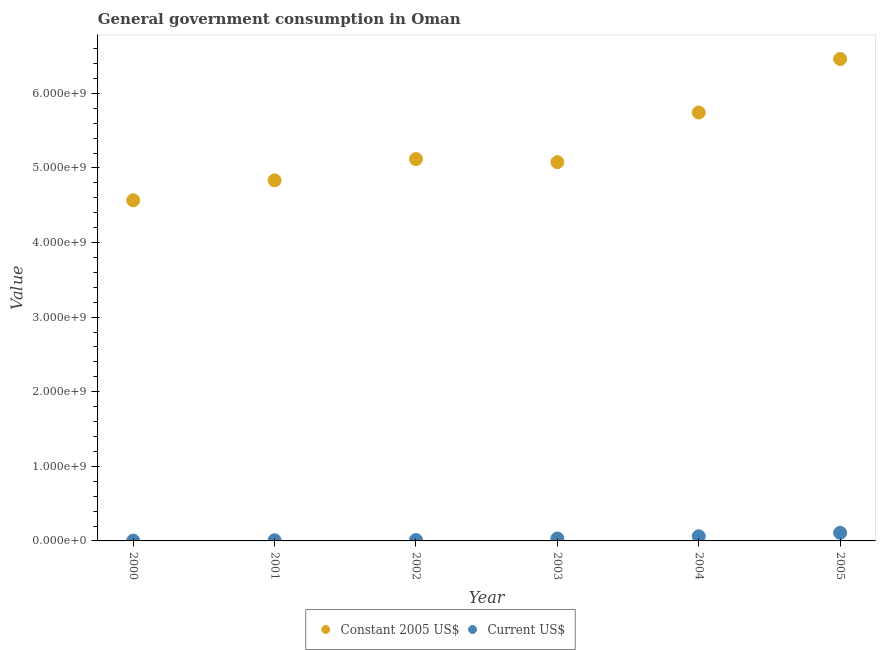What is the value consumed in constant 2005 us$ in 2001?
Your answer should be very brief. 4.83e+09. Across all years, what is the maximum value consumed in current us$?
Offer a terse response. 1.09e+08. Across all years, what is the minimum value consumed in constant 2005 us$?
Keep it short and to the point. 4.57e+09. What is the total value consumed in current us$ in the graph?
Provide a short and direct response. 2.30e+08. What is the difference between the value consumed in constant 2005 us$ in 2000 and that in 2001?
Make the answer very short. -2.68e+08. What is the difference between the value consumed in current us$ in 2003 and the value consumed in constant 2005 us$ in 2002?
Offer a very short reply. -5.09e+09. What is the average value consumed in current us$ per year?
Your answer should be compact. 3.84e+07. In the year 2002, what is the difference between the value consumed in constant 2005 us$ and value consumed in current us$?
Give a very brief answer. 5.11e+09. What is the ratio of the value consumed in constant 2005 us$ in 2003 to that in 2005?
Offer a terse response. 0.79. Is the value consumed in constant 2005 us$ in 2000 less than that in 2001?
Provide a succinct answer. Yes. Is the difference between the value consumed in current us$ in 2004 and 2005 greater than the difference between the value consumed in constant 2005 us$ in 2004 and 2005?
Provide a short and direct response. Yes. What is the difference between the highest and the second highest value consumed in current us$?
Provide a short and direct response. 4.61e+07. What is the difference between the highest and the lowest value consumed in current us$?
Your answer should be very brief. 1.04e+08. In how many years, is the value consumed in current us$ greater than the average value consumed in current us$ taken over all years?
Offer a very short reply. 2. Is the sum of the value consumed in current us$ in 2000 and 2002 greater than the maximum value consumed in constant 2005 us$ across all years?
Your answer should be compact. No. Does the value consumed in current us$ monotonically increase over the years?
Offer a very short reply. Yes. Is the value consumed in constant 2005 us$ strictly greater than the value consumed in current us$ over the years?
Provide a short and direct response. Yes. How many years are there in the graph?
Offer a terse response. 6. Does the graph contain any zero values?
Provide a succinct answer. No. Where does the legend appear in the graph?
Your answer should be compact. Bottom center. How many legend labels are there?
Give a very brief answer. 2. What is the title of the graph?
Your response must be concise. General government consumption in Oman. What is the label or title of the Y-axis?
Give a very brief answer. Value. What is the Value in Constant 2005 US$ in 2000?
Your answer should be compact. 4.57e+09. What is the Value of Current US$ in 2000?
Offer a very short reply. 4.69e+06. What is the Value in Constant 2005 US$ in 2001?
Give a very brief answer. 4.83e+09. What is the Value of Current US$ in 2001?
Offer a terse response. 9.12e+06. What is the Value in Constant 2005 US$ in 2002?
Keep it short and to the point. 5.12e+09. What is the Value in Current US$ in 2002?
Offer a very short reply. 1.22e+07. What is the Value of Constant 2005 US$ in 2003?
Offer a very short reply. 5.08e+09. What is the Value in Current US$ in 2003?
Your answer should be compact. 3.29e+07. What is the Value of Constant 2005 US$ in 2004?
Keep it short and to the point. 5.74e+09. What is the Value in Current US$ in 2004?
Provide a short and direct response. 6.26e+07. What is the Value of Constant 2005 US$ in 2005?
Offer a terse response. 6.46e+09. What is the Value in Current US$ in 2005?
Provide a short and direct response. 1.09e+08. Across all years, what is the maximum Value in Constant 2005 US$?
Your answer should be compact. 6.46e+09. Across all years, what is the maximum Value of Current US$?
Ensure brevity in your answer.  1.09e+08. Across all years, what is the minimum Value of Constant 2005 US$?
Keep it short and to the point. 4.57e+09. Across all years, what is the minimum Value of Current US$?
Give a very brief answer. 4.69e+06. What is the total Value in Constant 2005 US$ in the graph?
Ensure brevity in your answer.  3.18e+1. What is the total Value in Current US$ in the graph?
Your answer should be compact. 2.30e+08. What is the difference between the Value in Constant 2005 US$ in 2000 and that in 2001?
Offer a terse response. -2.68e+08. What is the difference between the Value in Current US$ in 2000 and that in 2001?
Your response must be concise. -4.43e+06. What is the difference between the Value of Constant 2005 US$ in 2000 and that in 2002?
Provide a succinct answer. -5.53e+08. What is the difference between the Value in Current US$ in 2000 and that in 2002?
Your response must be concise. -7.55e+06. What is the difference between the Value of Constant 2005 US$ in 2000 and that in 2003?
Give a very brief answer. -5.12e+08. What is the difference between the Value of Current US$ in 2000 and that in 2003?
Provide a short and direct response. -2.82e+07. What is the difference between the Value of Constant 2005 US$ in 2000 and that in 2004?
Provide a short and direct response. -1.18e+09. What is the difference between the Value in Current US$ in 2000 and that in 2004?
Your response must be concise. -5.79e+07. What is the difference between the Value in Constant 2005 US$ in 2000 and that in 2005?
Offer a terse response. -1.90e+09. What is the difference between the Value in Current US$ in 2000 and that in 2005?
Keep it short and to the point. -1.04e+08. What is the difference between the Value of Constant 2005 US$ in 2001 and that in 2002?
Provide a short and direct response. -2.85e+08. What is the difference between the Value in Current US$ in 2001 and that in 2002?
Your answer should be very brief. -3.12e+06. What is the difference between the Value in Constant 2005 US$ in 2001 and that in 2003?
Offer a very short reply. -2.44e+08. What is the difference between the Value of Current US$ in 2001 and that in 2003?
Give a very brief answer. -2.38e+07. What is the difference between the Value of Constant 2005 US$ in 2001 and that in 2004?
Your answer should be very brief. -9.09e+08. What is the difference between the Value in Current US$ in 2001 and that in 2004?
Offer a terse response. -5.34e+07. What is the difference between the Value in Constant 2005 US$ in 2001 and that in 2005?
Offer a very short reply. -1.63e+09. What is the difference between the Value of Current US$ in 2001 and that in 2005?
Offer a terse response. -9.95e+07. What is the difference between the Value in Constant 2005 US$ in 2002 and that in 2003?
Your answer should be very brief. 4.12e+07. What is the difference between the Value in Current US$ in 2002 and that in 2003?
Keep it short and to the point. -2.06e+07. What is the difference between the Value in Constant 2005 US$ in 2002 and that in 2004?
Your answer should be compact. -6.24e+08. What is the difference between the Value of Current US$ in 2002 and that in 2004?
Your answer should be very brief. -5.03e+07. What is the difference between the Value in Constant 2005 US$ in 2002 and that in 2005?
Make the answer very short. -1.34e+09. What is the difference between the Value of Current US$ in 2002 and that in 2005?
Your response must be concise. -9.64e+07. What is the difference between the Value of Constant 2005 US$ in 2003 and that in 2004?
Your answer should be very brief. -6.65e+08. What is the difference between the Value of Current US$ in 2003 and that in 2004?
Your answer should be compact. -2.97e+07. What is the difference between the Value of Constant 2005 US$ in 2003 and that in 2005?
Offer a terse response. -1.38e+09. What is the difference between the Value in Current US$ in 2003 and that in 2005?
Keep it short and to the point. -7.58e+07. What is the difference between the Value in Constant 2005 US$ in 2004 and that in 2005?
Ensure brevity in your answer.  -7.18e+08. What is the difference between the Value of Current US$ in 2004 and that in 2005?
Give a very brief answer. -4.61e+07. What is the difference between the Value in Constant 2005 US$ in 2000 and the Value in Current US$ in 2001?
Provide a short and direct response. 4.56e+09. What is the difference between the Value in Constant 2005 US$ in 2000 and the Value in Current US$ in 2002?
Your answer should be very brief. 4.55e+09. What is the difference between the Value in Constant 2005 US$ in 2000 and the Value in Current US$ in 2003?
Offer a terse response. 4.53e+09. What is the difference between the Value in Constant 2005 US$ in 2000 and the Value in Current US$ in 2004?
Offer a very short reply. 4.50e+09. What is the difference between the Value of Constant 2005 US$ in 2000 and the Value of Current US$ in 2005?
Your answer should be very brief. 4.46e+09. What is the difference between the Value in Constant 2005 US$ in 2001 and the Value in Current US$ in 2002?
Provide a succinct answer. 4.82e+09. What is the difference between the Value of Constant 2005 US$ in 2001 and the Value of Current US$ in 2003?
Your response must be concise. 4.80e+09. What is the difference between the Value in Constant 2005 US$ in 2001 and the Value in Current US$ in 2004?
Your response must be concise. 4.77e+09. What is the difference between the Value in Constant 2005 US$ in 2001 and the Value in Current US$ in 2005?
Provide a succinct answer. 4.73e+09. What is the difference between the Value of Constant 2005 US$ in 2002 and the Value of Current US$ in 2003?
Provide a short and direct response. 5.09e+09. What is the difference between the Value in Constant 2005 US$ in 2002 and the Value in Current US$ in 2004?
Ensure brevity in your answer.  5.06e+09. What is the difference between the Value of Constant 2005 US$ in 2002 and the Value of Current US$ in 2005?
Provide a short and direct response. 5.01e+09. What is the difference between the Value in Constant 2005 US$ in 2003 and the Value in Current US$ in 2004?
Your answer should be compact. 5.02e+09. What is the difference between the Value of Constant 2005 US$ in 2003 and the Value of Current US$ in 2005?
Ensure brevity in your answer.  4.97e+09. What is the difference between the Value in Constant 2005 US$ in 2004 and the Value in Current US$ in 2005?
Your answer should be compact. 5.63e+09. What is the average Value of Constant 2005 US$ per year?
Your answer should be very brief. 5.30e+09. What is the average Value of Current US$ per year?
Your answer should be compact. 3.84e+07. In the year 2000, what is the difference between the Value in Constant 2005 US$ and Value in Current US$?
Make the answer very short. 4.56e+09. In the year 2001, what is the difference between the Value in Constant 2005 US$ and Value in Current US$?
Your answer should be compact. 4.83e+09. In the year 2002, what is the difference between the Value in Constant 2005 US$ and Value in Current US$?
Provide a short and direct response. 5.11e+09. In the year 2003, what is the difference between the Value in Constant 2005 US$ and Value in Current US$?
Give a very brief answer. 5.05e+09. In the year 2004, what is the difference between the Value in Constant 2005 US$ and Value in Current US$?
Ensure brevity in your answer.  5.68e+09. In the year 2005, what is the difference between the Value of Constant 2005 US$ and Value of Current US$?
Your answer should be compact. 6.35e+09. What is the ratio of the Value in Constant 2005 US$ in 2000 to that in 2001?
Your response must be concise. 0.94. What is the ratio of the Value in Current US$ in 2000 to that in 2001?
Offer a terse response. 0.51. What is the ratio of the Value of Constant 2005 US$ in 2000 to that in 2002?
Provide a succinct answer. 0.89. What is the ratio of the Value in Current US$ in 2000 to that in 2002?
Ensure brevity in your answer.  0.38. What is the ratio of the Value of Constant 2005 US$ in 2000 to that in 2003?
Keep it short and to the point. 0.9. What is the ratio of the Value in Current US$ in 2000 to that in 2003?
Keep it short and to the point. 0.14. What is the ratio of the Value in Constant 2005 US$ in 2000 to that in 2004?
Give a very brief answer. 0.8. What is the ratio of the Value in Current US$ in 2000 to that in 2004?
Provide a succinct answer. 0.07. What is the ratio of the Value in Constant 2005 US$ in 2000 to that in 2005?
Ensure brevity in your answer.  0.71. What is the ratio of the Value in Current US$ in 2000 to that in 2005?
Give a very brief answer. 0.04. What is the ratio of the Value of Constant 2005 US$ in 2001 to that in 2002?
Keep it short and to the point. 0.94. What is the ratio of the Value in Current US$ in 2001 to that in 2002?
Give a very brief answer. 0.75. What is the ratio of the Value of Current US$ in 2001 to that in 2003?
Provide a short and direct response. 0.28. What is the ratio of the Value in Constant 2005 US$ in 2001 to that in 2004?
Offer a very short reply. 0.84. What is the ratio of the Value in Current US$ in 2001 to that in 2004?
Your response must be concise. 0.15. What is the ratio of the Value in Constant 2005 US$ in 2001 to that in 2005?
Make the answer very short. 0.75. What is the ratio of the Value in Current US$ in 2001 to that in 2005?
Your answer should be compact. 0.08. What is the ratio of the Value of Constant 2005 US$ in 2002 to that in 2003?
Provide a short and direct response. 1.01. What is the ratio of the Value in Current US$ in 2002 to that in 2003?
Make the answer very short. 0.37. What is the ratio of the Value in Constant 2005 US$ in 2002 to that in 2004?
Give a very brief answer. 0.89. What is the ratio of the Value of Current US$ in 2002 to that in 2004?
Your answer should be very brief. 0.2. What is the ratio of the Value of Constant 2005 US$ in 2002 to that in 2005?
Your answer should be very brief. 0.79. What is the ratio of the Value in Current US$ in 2002 to that in 2005?
Give a very brief answer. 0.11. What is the ratio of the Value in Constant 2005 US$ in 2003 to that in 2004?
Your answer should be compact. 0.88. What is the ratio of the Value in Current US$ in 2003 to that in 2004?
Your answer should be very brief. 0.53. What is the ratio of the Value in Constant 2005 US$ in 2003 to that in 2005?
Your response must be concise. 0.79. What is the ratio of the Value in Current US$ in 2003 to that in 2005?
Offer a terse response. 0.3. What is the ratio of the Value of Constant 2005 US$ in 2004 to that in 2005?
Ensure brevity in your answer.  0.89. What is the ratio of the Value of Current US$ in 2004 to that in 2005?
Your answer should be very brief. 0.58. What is the difference between the highest and the second highest Value of Constant 2005 US$?
Ensure brevity in your answer.  7.18e+08. What is the difference between the highest and the second highest Value of Current US$?
Offer a very short reply. 4.61e+07. What is the difference between the highest and the lowest Value of Constant 2005 US$?
Your answer should be very brief. 1.90e+09. What is the difference between the highest and the lowest Value of Current US$?
Your answer should be very brief. 1.04e+08. 